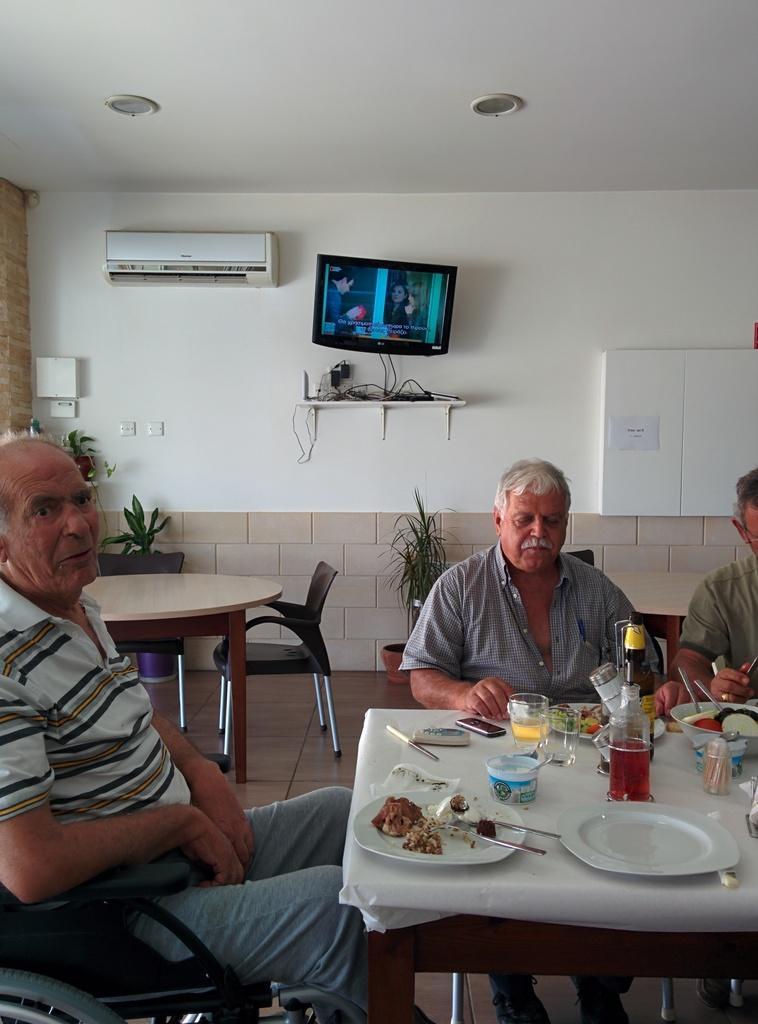Could you give a brief overview of what you see in this image? In this image three old persons are sitting on chair. In front of them there is a table on the table there are plates,food,bottle,cup and few other thing. Here is another dining table with chairs. There are few plants, there is an ac mounted over here, there is a tv mounted over here in the background. 